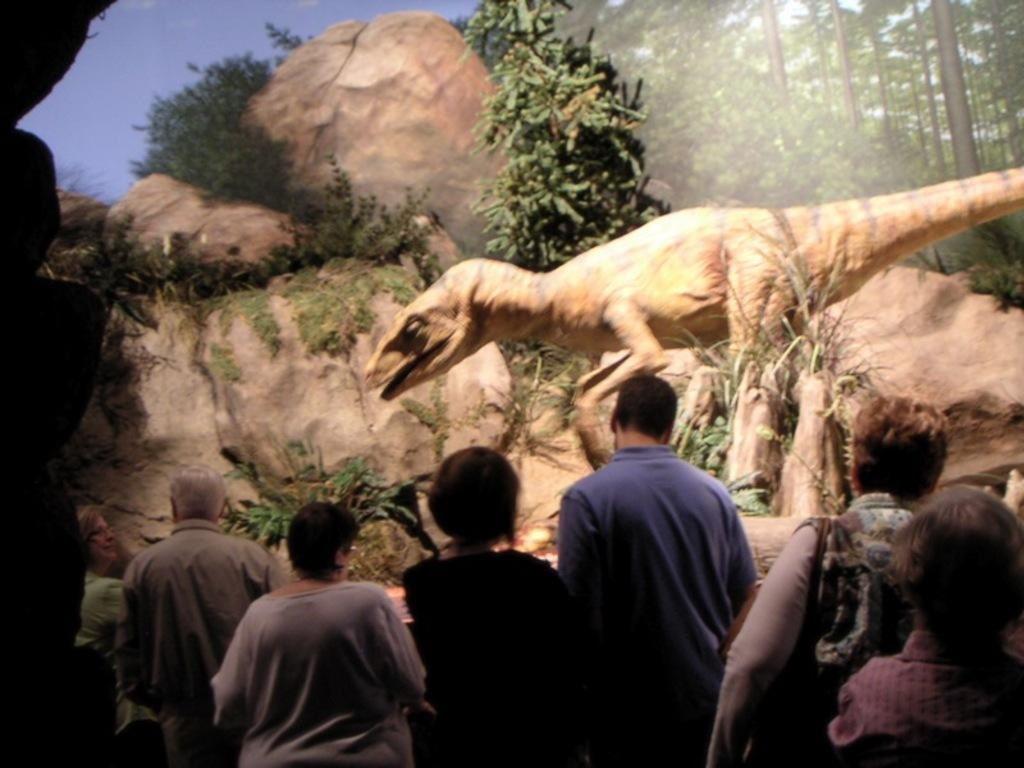Who or what can be seen at the bottom of the image? There are persons at the bottom of the image. What is the main subject in the center of the image? There is a dinosaur in the center of the image. What type of natural elements are visible in the background of the image? There are rocks, trees, and the sky visible in the background of the image. What type of brush is being used by the person in the image? There is no brush present in the image; it features a dinosaur and persons at the bottom. Can you describe the bedroom setting in the image? There is no bedroom setting present in the image; it features a dinosaur and persons at the bottom. 